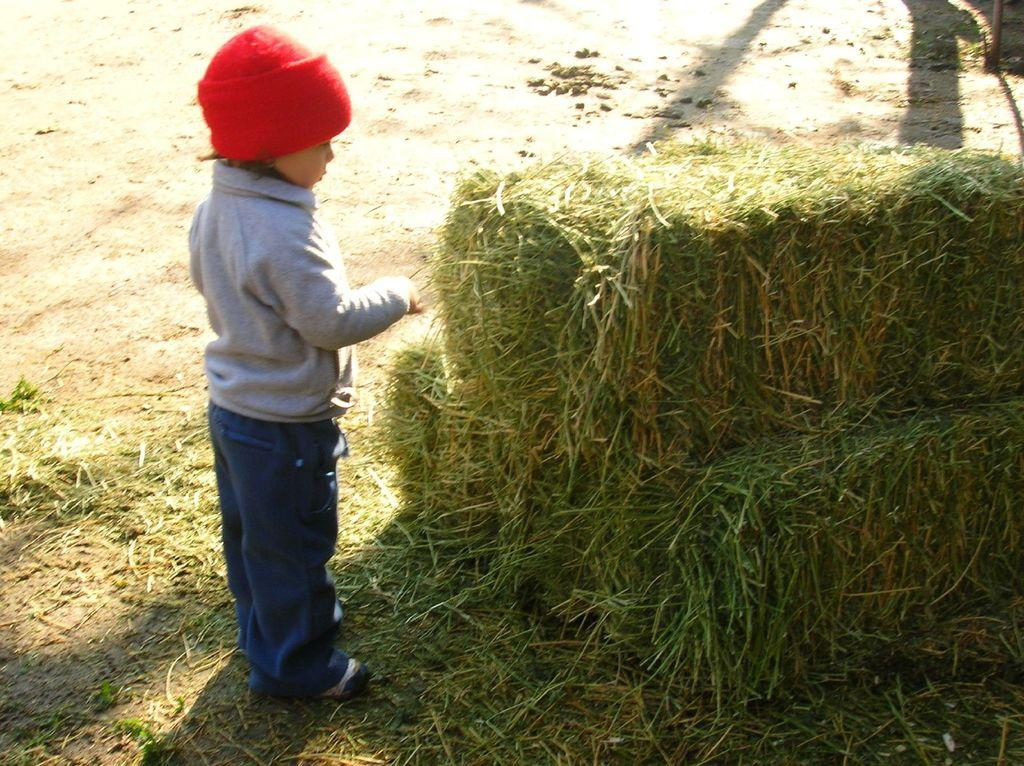What is the main subject of the image? The main subject of the image is a kid. Where is the kid standing in the image? The kid is standing on the ground. What type of terrain is visible in the image? There is grass visible in the image. What type of office furniture can be seen in the image? There is no office furniture present in the image; it features a kid standing on grass. Are there any nails visible on the kid's hands in the image? There are no nails visible on the kid's hands in the image. 